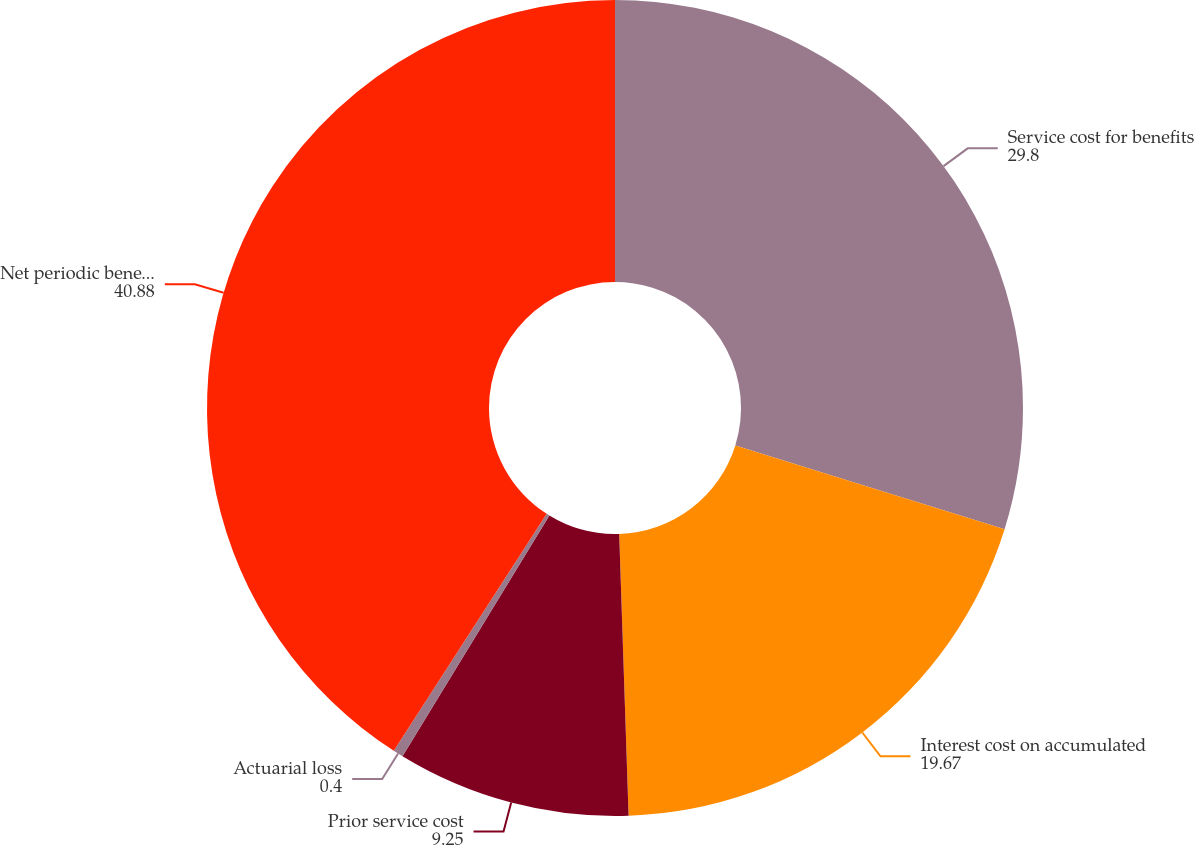<chart> <loc_0><loc_0><loc_500><loc_500><pie_chart><fcel>Service cost for benefits<fcel>Interest cost on accumulated<fcel>Prior service cost<fcel>Actuarial loss<fcel>Net periodic benefit cost<nl><fcel>29.8%<fcel>19.67%<fcel>9.25%<fcel>0.4%<fcel>40.88%<nl></chart> 